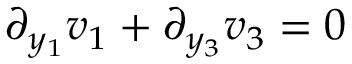<formula> <loc_0><loc_0><loc_500><loc_500>\partial _ { y _ { 1 } } v _ { 1 } + \partial _ { y _ { 3 } } v _ { 3 } = 0</formula> 